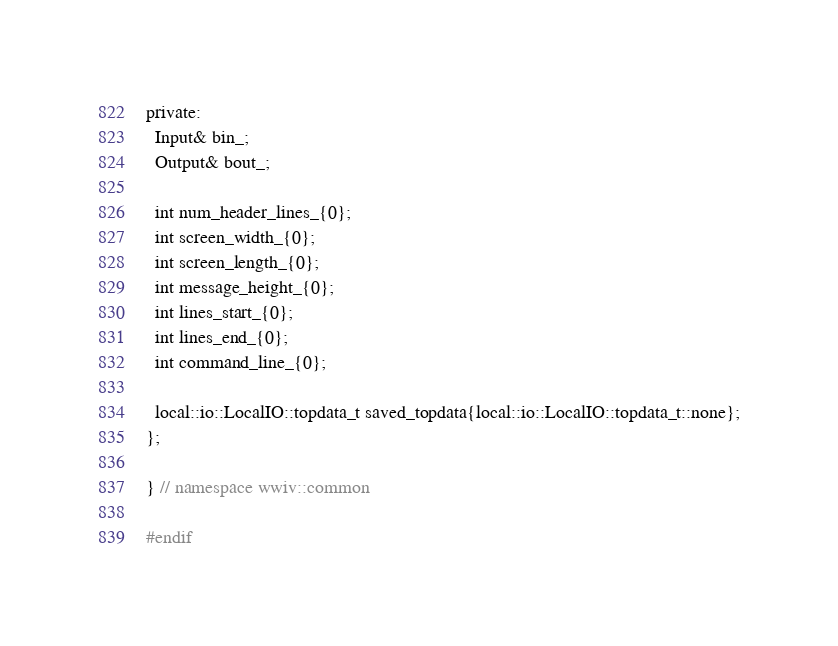<code> <loc_0><loc_0><loc_500><loc_500><_C_>
private:
  Input& bin_;
  Output& bout_;

  int num_header_lines_{0};
  int screen_width_{0};
  int screen_length_{0};
  int message_height_{0};
  int lines_start_{0};
  int lines_end_{0};
  int command_line_{0};

  local::io::LocalIO::topdata_t saved_topdata{local::io::LocalIO::topdata_t::none};
};

} // namespace wwiv::common

#endif
</code> 